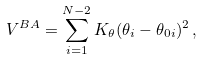<formula> <loc_0><loc_0><loc_500><loc_500>V ^ { B A } = \sum _ { i = 1 } ^ { N - 2 } K _ { \theta } ( \theta _ { i } - \theta _ { 0 i } ) ^ { 2 } \, ,</formula> 